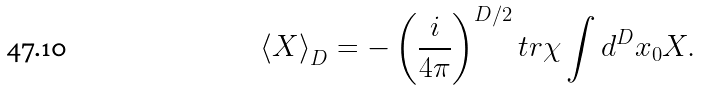<formula> <loc_0><loc_0><loc_500><loc_500>\left \langle X \right \rangle _ { D } = - \left ( \frac { i } { 4 \pi } \right ) ^ { D / 2 } t r \chi \int d ^ { D } x _ { 0 } X .</formula> 